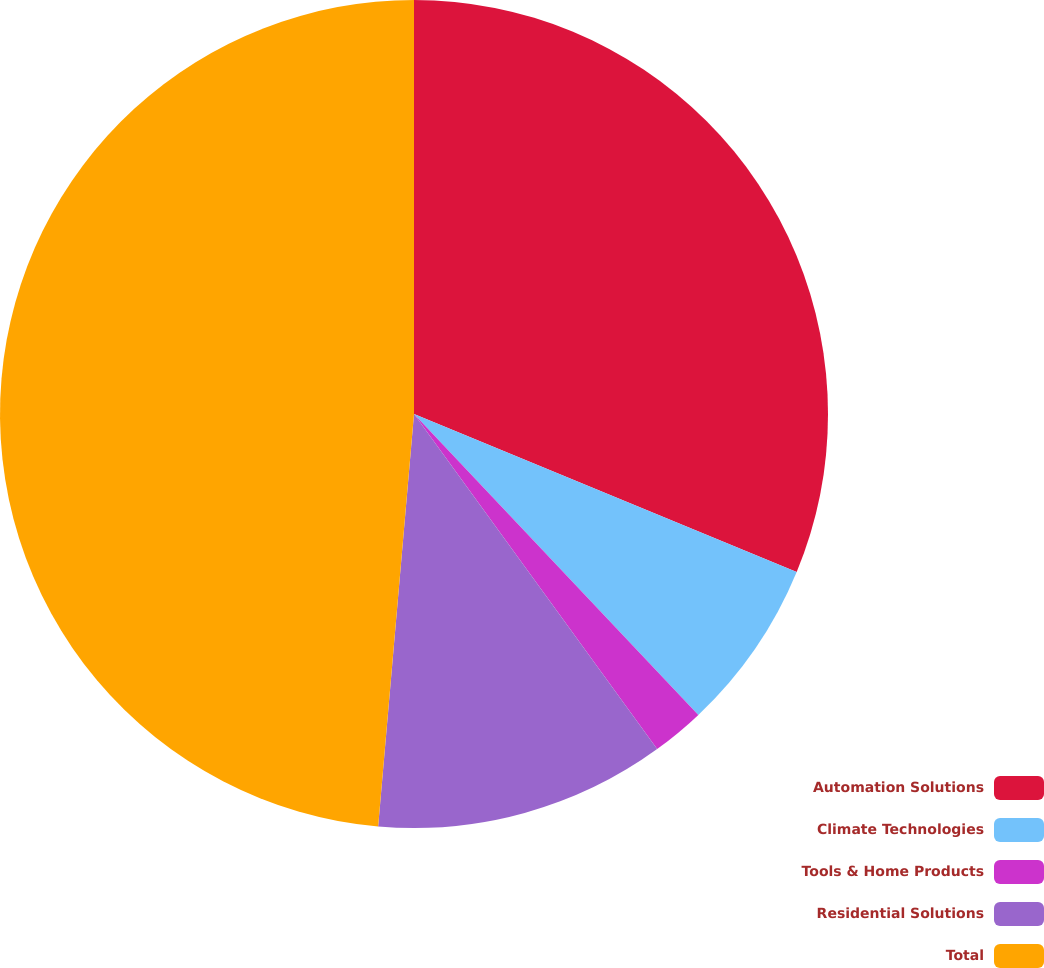<chart> <loc_0><loc_0><loc_500><loc_500><pie_chart><fcel>Automation Solutions<fcel>Climate Technologies<fcel>Tools & Home Products<fcel>Residential Solutions<fcel>Total<nl><fcel>31.23%<fcel>6.72%<fcel>2.06%<fcel>11.37%<fcel>48.62%<nl></chart> 